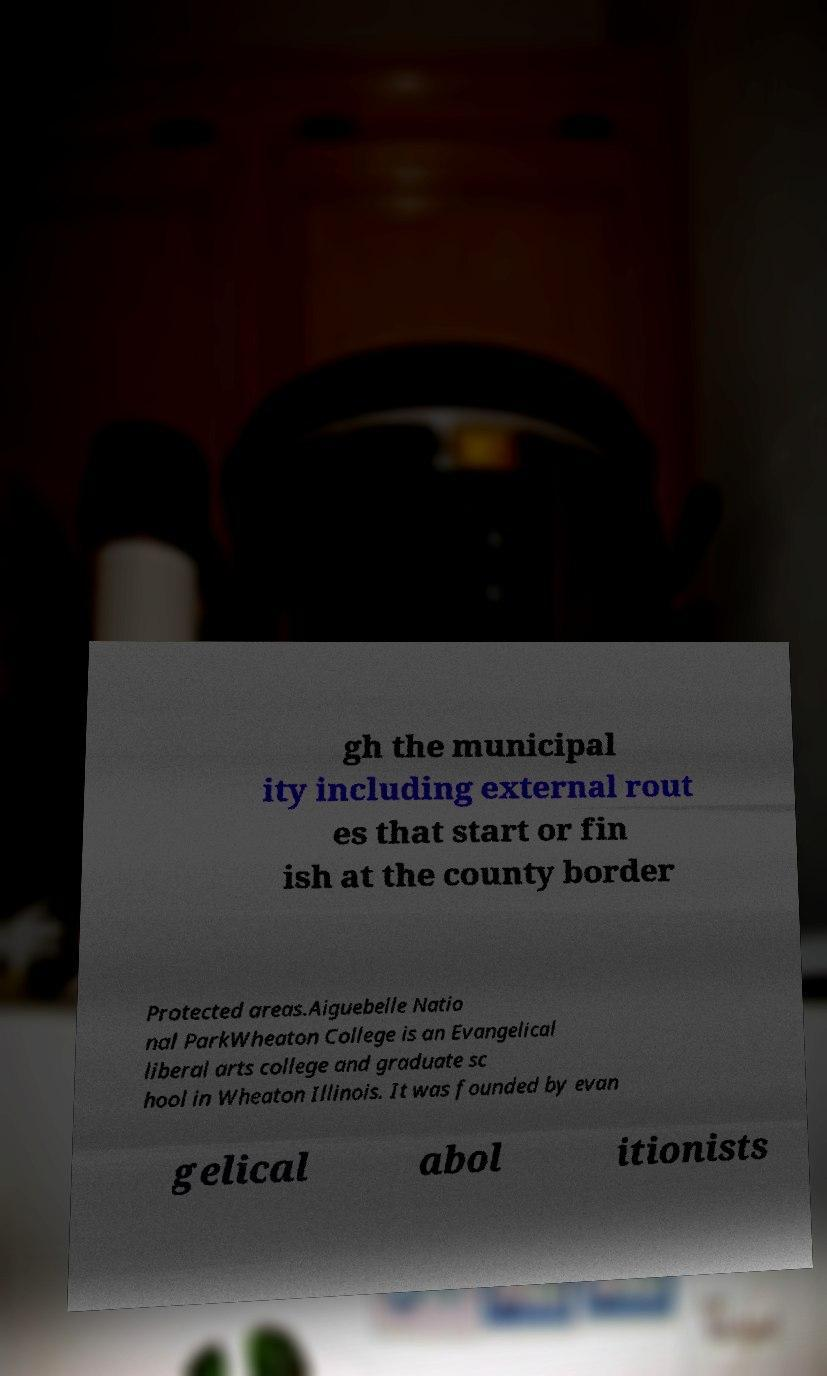Could you assist in decoding the text presented in this image and type it out clearly? gh the municipal ity including external rout es that start or fin ish at the county border Protected areas.Aiguebelle Natio nal ParkWheaton College is an Evangelical liberal arts college and graduate sc hool in Wheaton Illinois. It was founded by evan gelical abol itionists 